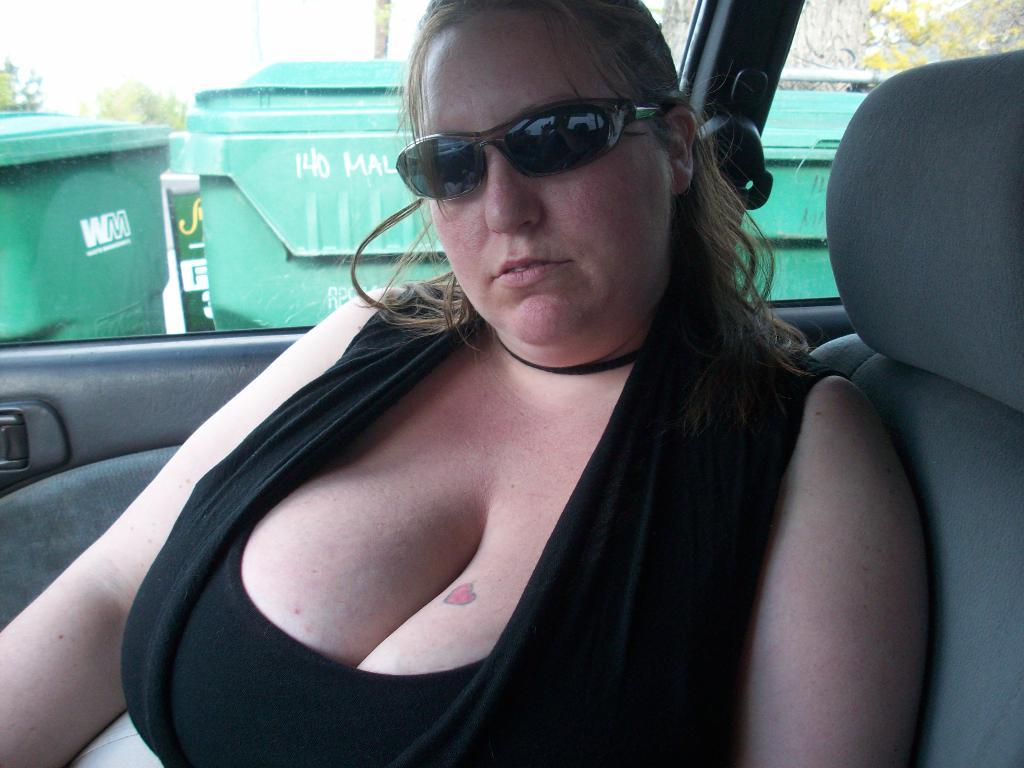Who is present in the image? There is a woman in the image. What is the woman wearing? The woman is wearing glasses. Where is the woman located in the image? The woman is sitting in a car. What can be seen behind the car? There is a glass window behind the car. What is visible through the glass window? Bins are visible through the glass window. What type of vegetation is present in the image? There are trees in the image. What type of pets are visible in the image? There are no pets present in the image. What color is the ball in the image? There is no mention of a ball in the image. 